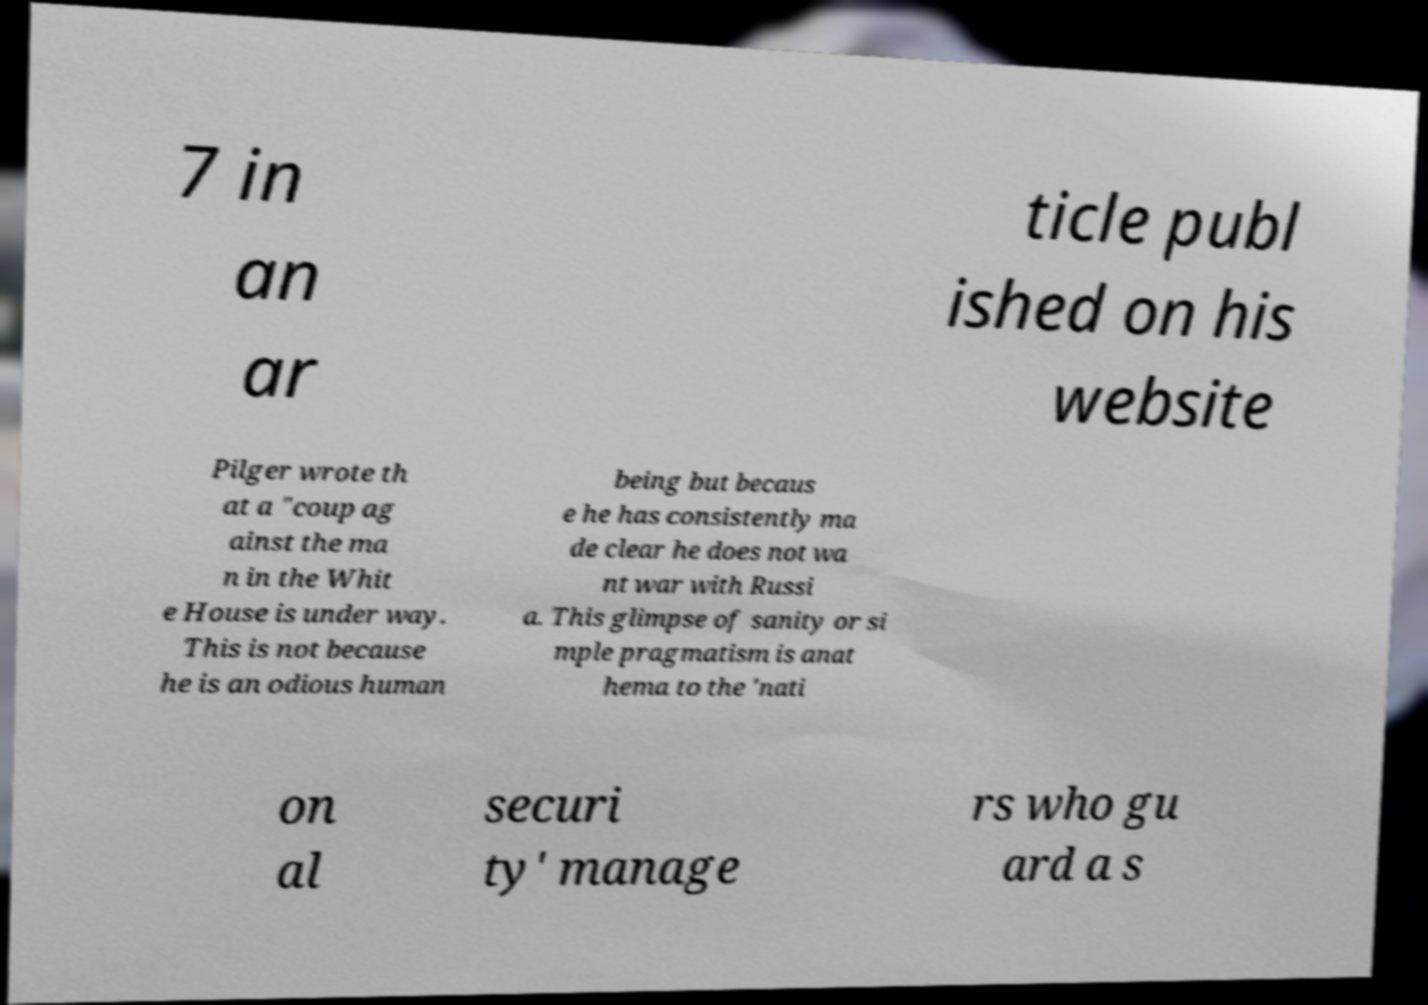Can you accurately transcribe the text from the provided image for me? 7 in an ar ticle publ ished on his website Pilger wrote th at a "coup ag ainst the ma n in the Whit e House is under way. This is not because he is an odious human being but becaus e he has consistently ma de clear he does not wa nt war with Russi a. This glimpse of sanity or si mple pragmatism is anat hema to the 'nati on al securi ty' manage rs who gu ard a s 